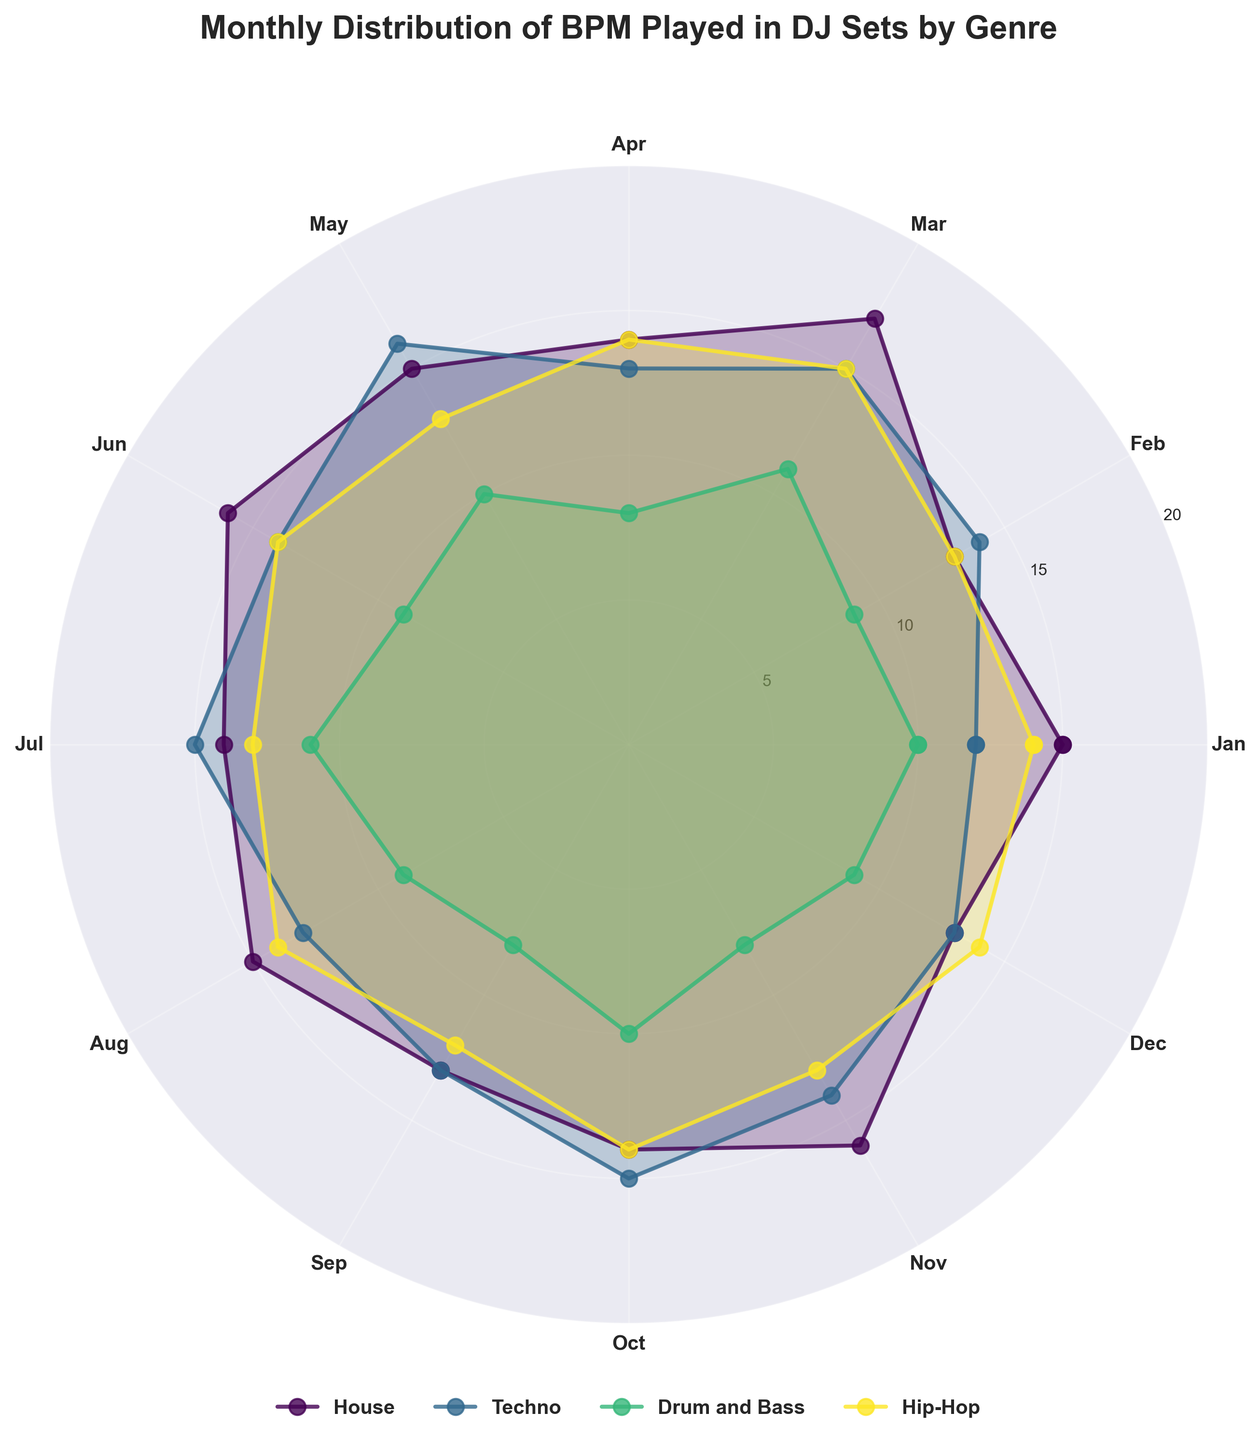What is the title of the chart? The title of the chart is written at the top and it provides a summary of the chart's purpose. The title shown is "Monthly Distribution of BPM Played in DJ Sets by Genre".
Answer: Monthly Distribution of BPM Played in DJ Sets by Genre How is the month of January represented on the chart? Each month is represented by a segment of the circle. The segment for January is the first one, positioned at the 12 o'clock mark.
Answer: By the segment starting from the top Which genre has the highest frequency of BPM played in May? By looking at the month of May on the chart, you can compare the heights of the bars. Techno has the highest frequency.
Answer: Techno Based on the chart, which genre shows the most consistency in BPM frequency across months? Consistent frequency is indicated by the bars being similar in height across the months. House and Hip-Hop show relatively consistent heights compared to Techno and Drum and Bass.
Answer: House and Hip-Hop What are the BPM values shown for the Techno genre? The chart displays BPM frequencies segmented by month. Techno exhibits BPM values of 130, 132, 131, 130, 133, 130, 132, 131, 130, 132, 130, and 131 with corresponding frequencies in each month.
Answer: 130, 132, 131, 130, 133, 130, 132, 131, 130, 132, 130, 131 During which months does Drum and Bass have a BPM frequency of 8? Refer to the segment heights for Drum and Bass specifically. The frequency of 8 BPM occurs in April, September, and November.
Answer: April, September, November Which genre has the smallest variation in BPM played throughout the year? Variation is observed based on segment heights' differences. Hip-Hop demonstrates minimal variation in BPM played across all months.
Answer: Hip-Hop How does the frequency of BPM played in July for House compare to that for Techno? Look at the heights of the bars corresponding to July for both genres. House has a frequency indicated at 14 and Techno at 15.
Answer: Techno is higher by 1 What patterns do you observe in the BPM distributions for House and Drum and Bass? By analyzing the side-by-side segments for House and Drum and Bass, one can observe that House maintains stable frequencies with slight variations around 15, while Drum and Bass has more pronounced variations, dipping to 8 in certain months.
Answer: House is stable; Drum and Bass shows more variation 